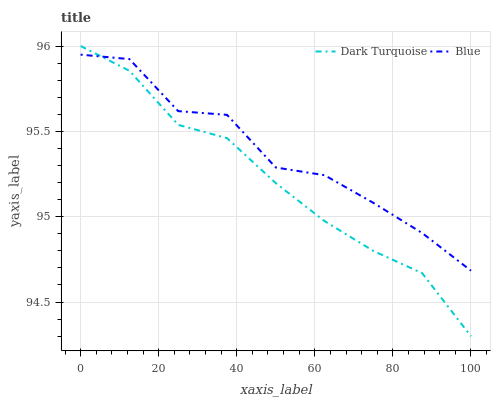Does Dark Turquoise have the minimum area under the curve?
Answer yes or no. Yes. Does Blue have the maximum area under the curve?
Answer yes or no. Yes. Does Dark Turquoise have the maximum area under the curve?
Answer yes or no. No. Is Dark Turquoise the smoothest?
Answer yes or no. Yes. Is Blue the roughest?
Answer yes or no. Yes. Is Dark Turquoise the roughest?
Answer yes or no. No. Does Dark Turquoise have the lowest value?
Answer yes or no. Yes. Does Dark Turquoise have the highest value?
Answer yes or no. Yes. Does Dark Turquoise intersect Blue?
Answer yes or no. Yes. Is Dark Turquoise less than Blue?
Answer yes or no. No. Is Dark Turquoise greater than Blue?
Answer yes or no. No. 